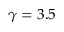<formula> <loc_0><loc_0><loc_500><loc_500>\gamma = 3 . 5</formula> 